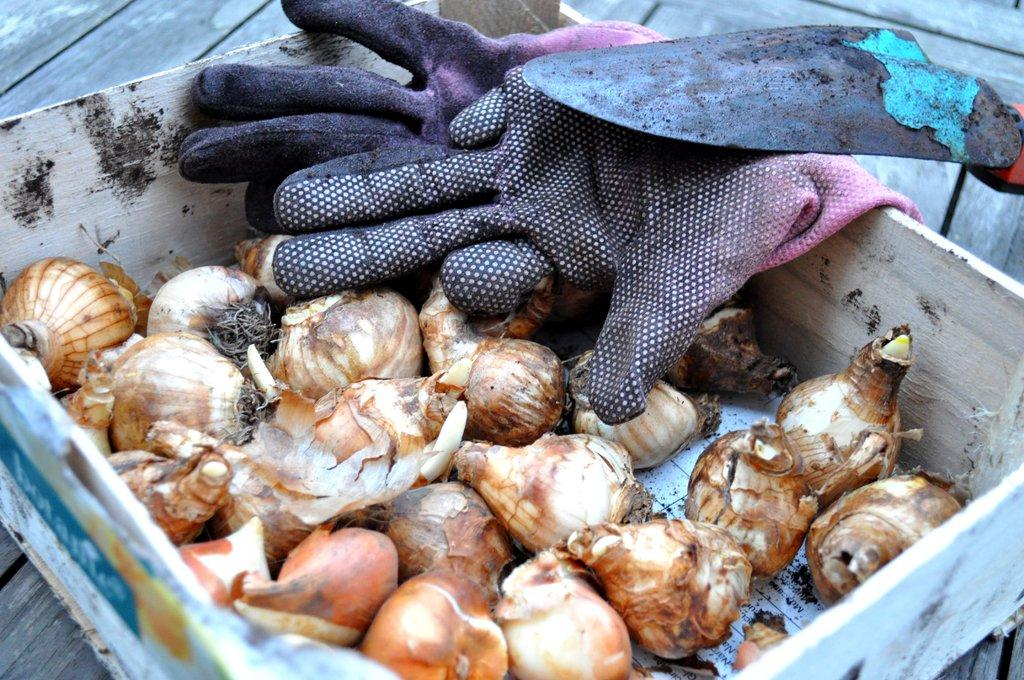What type of items are in the wooden box in the image? There is a group of vegetables in a wooden box in the image. What is the wooden box placed on? The wooden box is placed on a wooden surface. What additional items are on the wooden box? There are gloves and a shovel on the box. What type of brass instrument can be seen in the image? There is no brass instrument present in the image. 